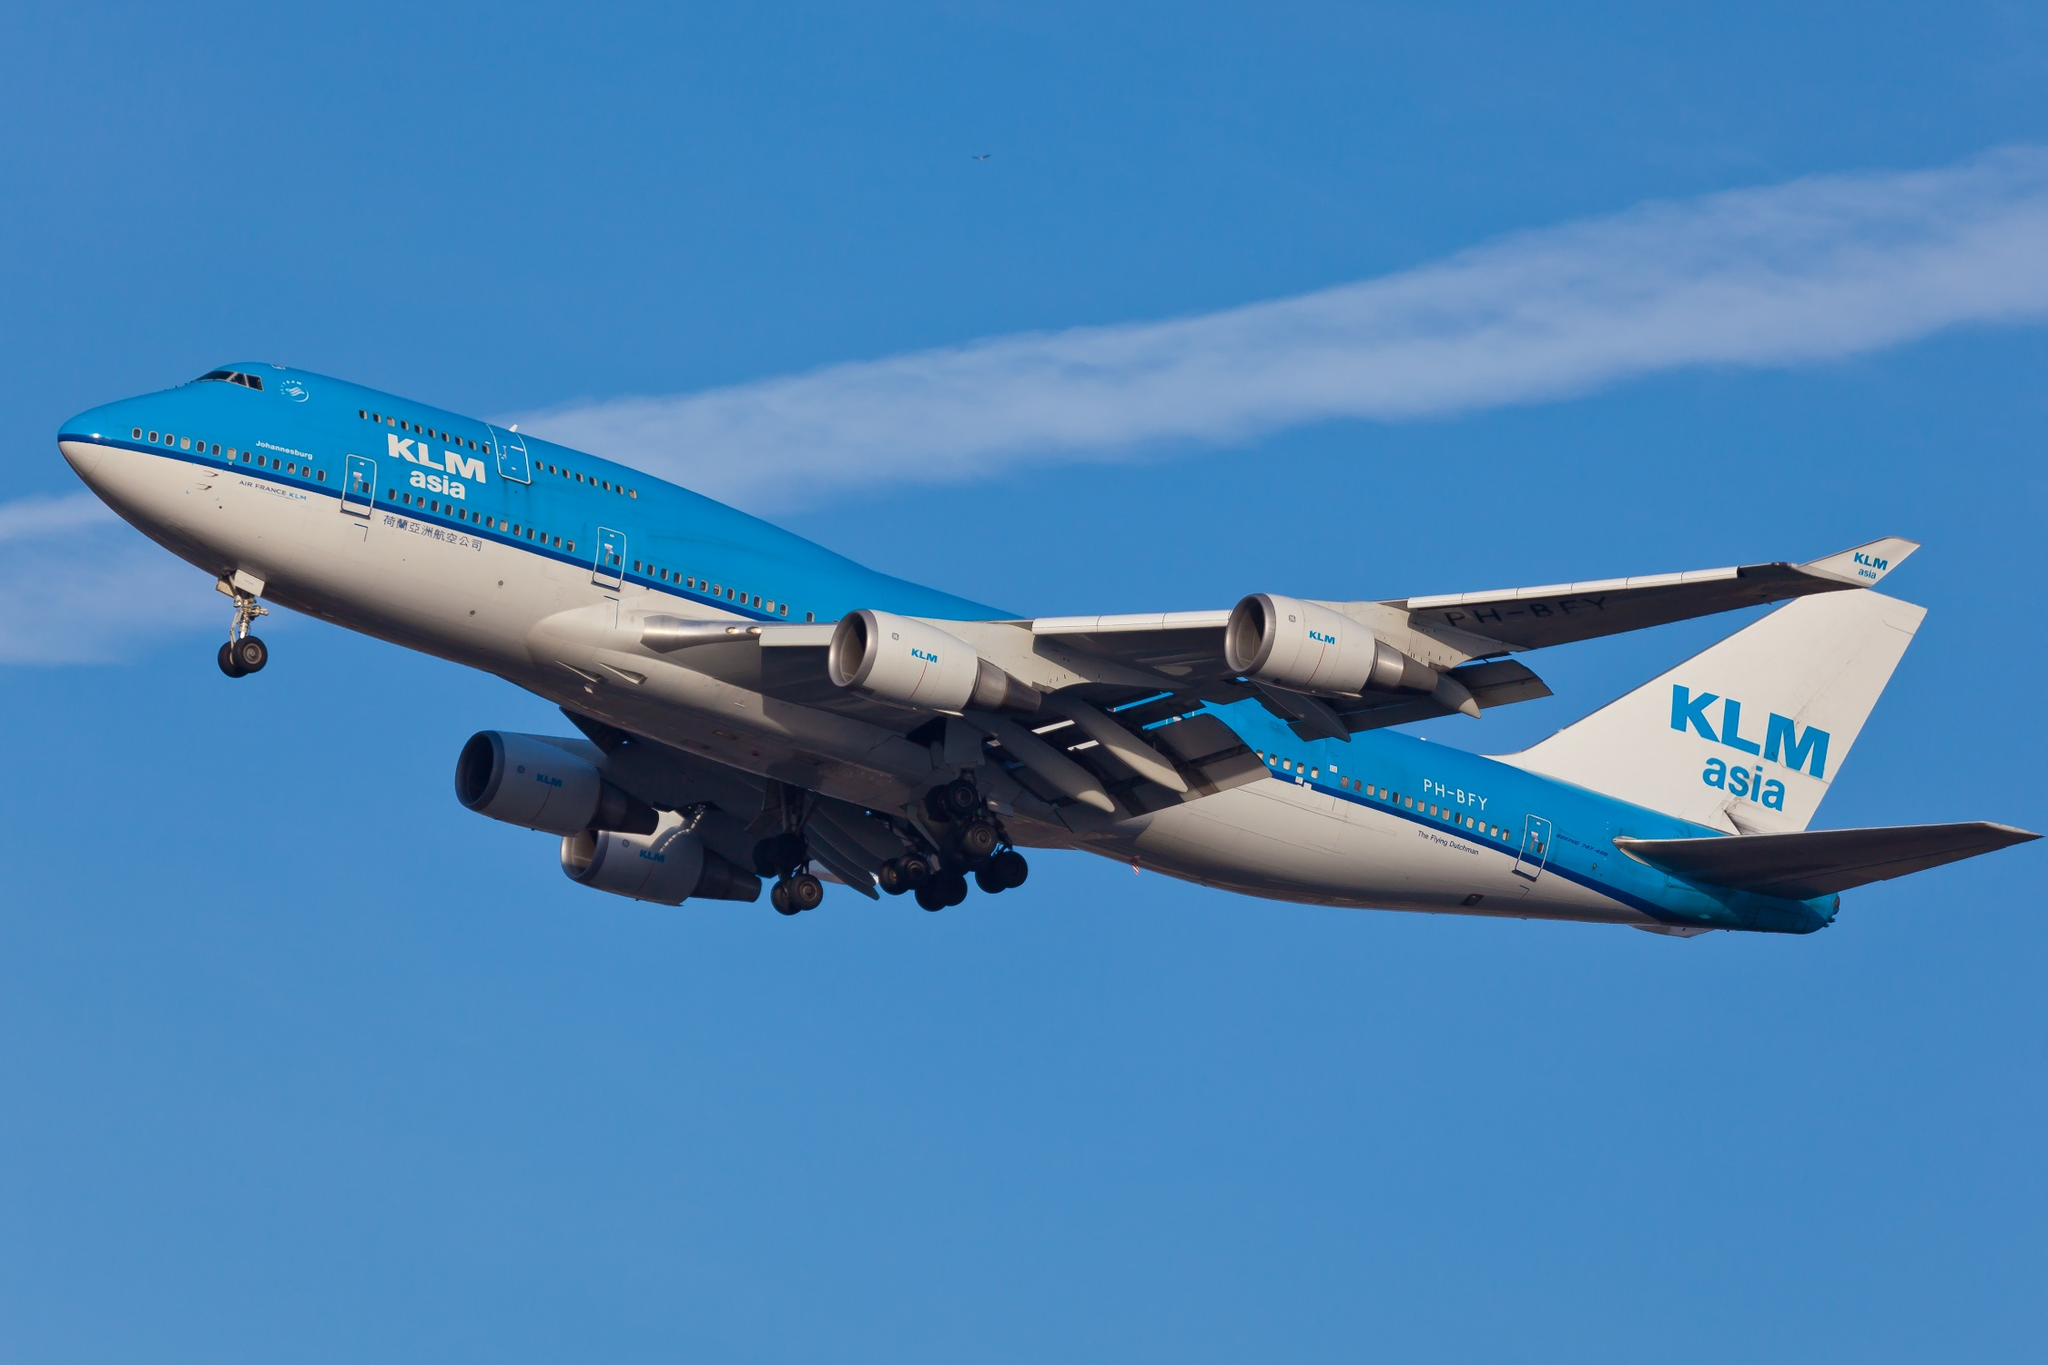What technological advancements in aviation are exemplified by this Boeing 747-400? The Boeing 747-400 model is a significant testament to advancements in aviation technology, particularly in the areas of aerodynamics, avionics, and fuel efficiency. Featuring a two-crew glass cockpit, advanced navigation technology, and more fuel-efficient engines compared to its predecessors, the 747-400 was a leap forward in long-haul travel. Its capacity to carry a large number of passengers and cargo over considerable distances non-stop is a direct result of innovations in airframe design and engine performance. Additionally, its operational cost efficiency and improved environmental impact through reduced fuel burn per passenger-kilometer mark pivotal improvements in sustainable aviation. 